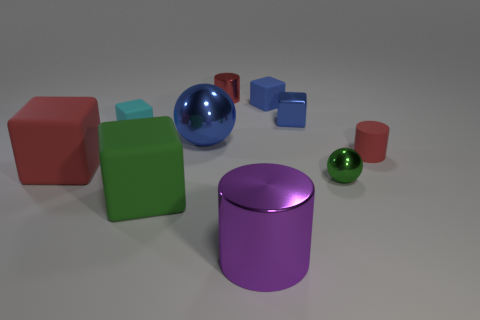Which object stands out the most to you and why? The large blue sphere stands out the most. Its vibrant color contrasts sharply with the other objects, and being a sphere, it breaks the pattern of the angular shapes around it.  How does the lighting in the image affect the appearance of the objects? The lighting creates soft shadows and highlights on the objects, giving them a three-dimensional appearance and adding depth to the scene. The reflections on the smoother objects, like the spheres and the cylinder, also draw attention and enhance their textures. 